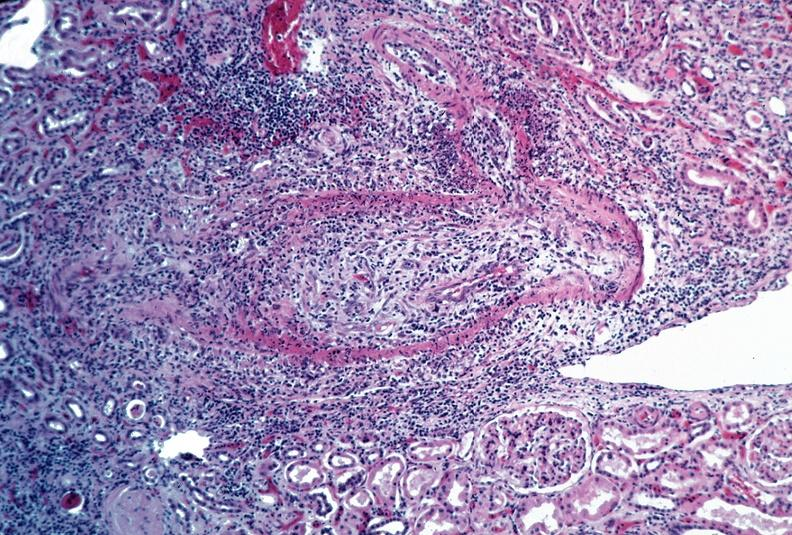s retroperitoneum present?
Answer the question using a single word or phrase. No 